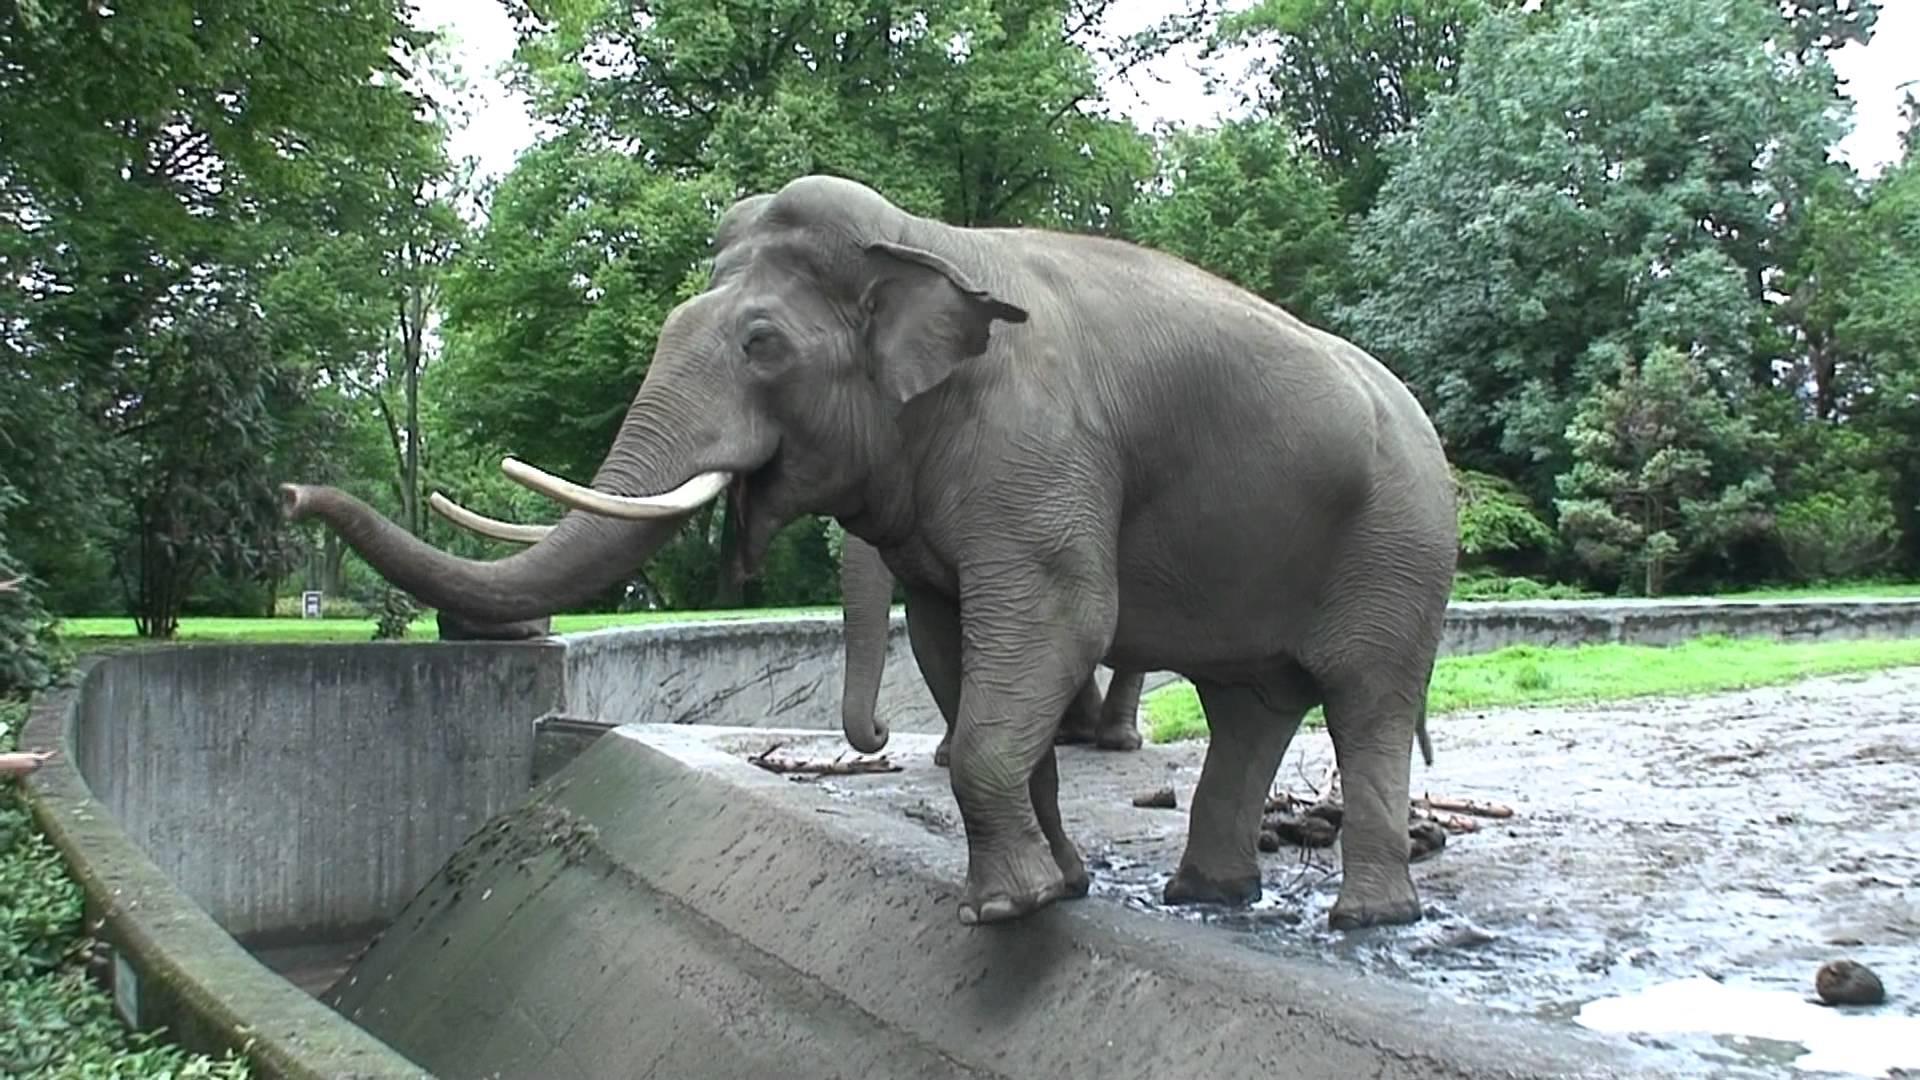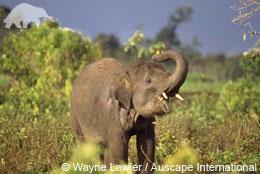The first image is the image on the left, the second image is the image on the right. Examine the images to the left and right. Is the description "The right image contains exactly one elephant." accurate? Answer yes or no. Yes. The first image is the image on the left, the second image is the image on the right. For the images shown, is this caption "There are two elephanfs in the image pair." true? Answer yes or no. Yes. 